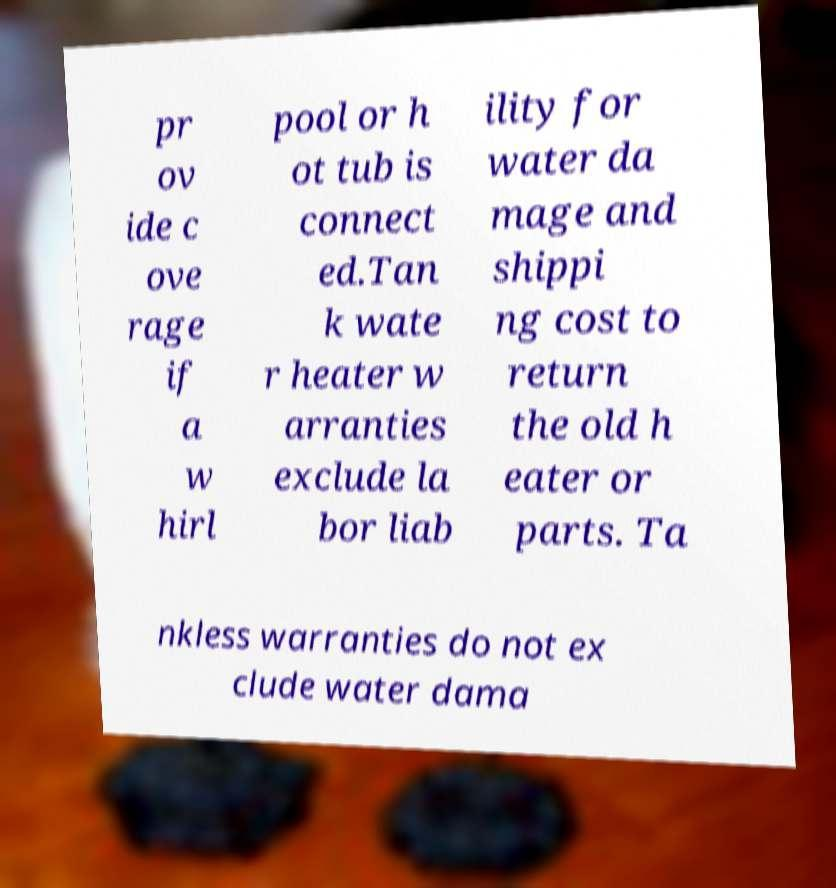Could you assist in decoding the text presented in this image and type it out clearly? pr ov ide c ove rage if a w hirl pool or h ot tub is connect ed.Tan k wate r heater w arranties exclude la bor liab ility for water da mage and shippi ng cost to return the old h eater or parts. Ta nkless warranties do not ex clude water dama 